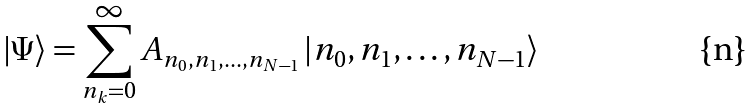Convert formula to latex. <formula><loc_0><loc_0><loc_500><loc_500>\left | \Psi \right \rangle = \sum _ { n _ { k } = 0 } ^ { \infty } A _ { n _ { 0 } , n _ { 1 } , \dots , n _ { N - 1 } } \left | n _ { 0 } , n _ { 1 } , \dots , n _ { N - 1 } \right \rangle</formula> 